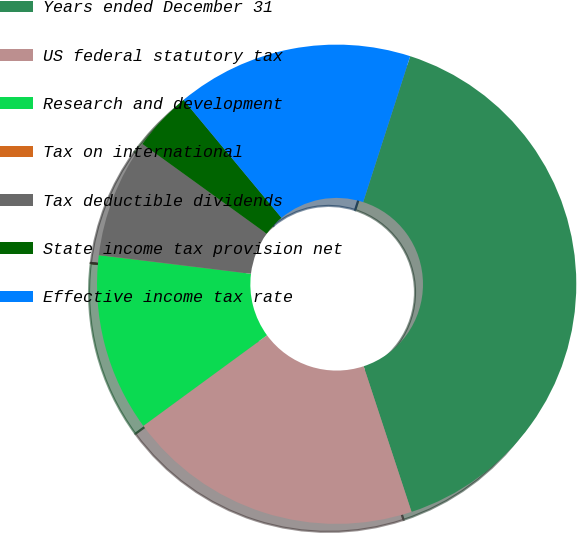Convert chart. <chart><loc_0><loc_0><loc_500><loc_500><pie_chart><fcel>Years ended December 31<fcel>US federal statutory tax<fcel>Research and development<fcel>Tax on international<fcel>Tax deductible dividends<fcel>State income tax provision net<fcel>Effective income tax rate<nl><fcel>39.98%<fcel>20.0%<fcel>12.0%<fcel>0.01%<fcel>8.01%<fcel>4.01%<fcel>16.0%<nl></chart> 